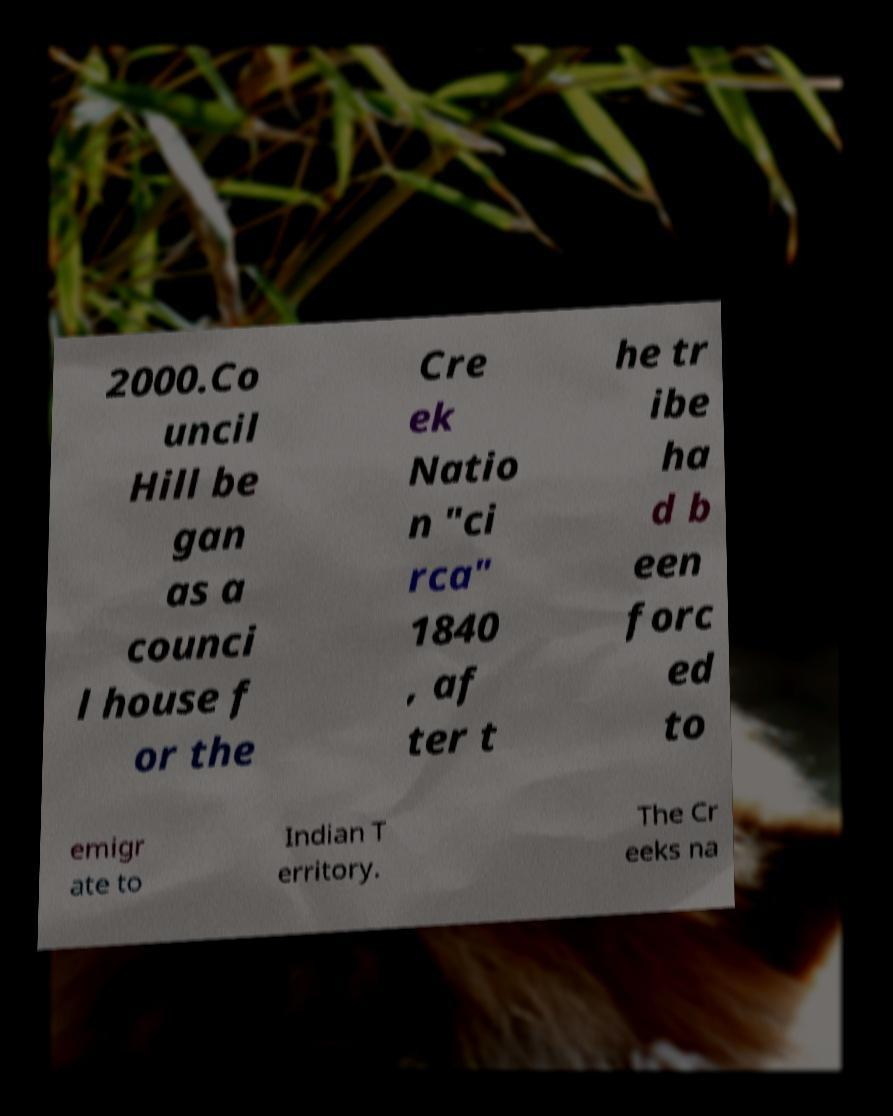Please identify and transcribe the text found in this image. 2000.Co uncil Hill be gan as a counci l house f or the Cre ek Natio n "ci rca" 1840 , af ter t he tr ibe ha d b een forc ed to emigr ate to Indian T erritory. The Cr eeks na 